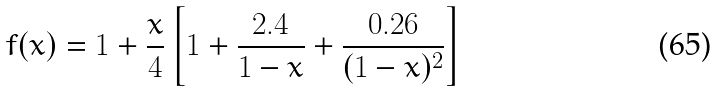Convert formula to latex. <formula><loc_0><loc_0><loc_500><loc_500>f ( x ) = 1 + \frac { x } { 4 } \left [ 1 + \frac { 2 . 4 } { 1 - x } + \frac { 0 . 2 6 } { ( 1 - x ) ^ { 2 } } \right ]</formula> 